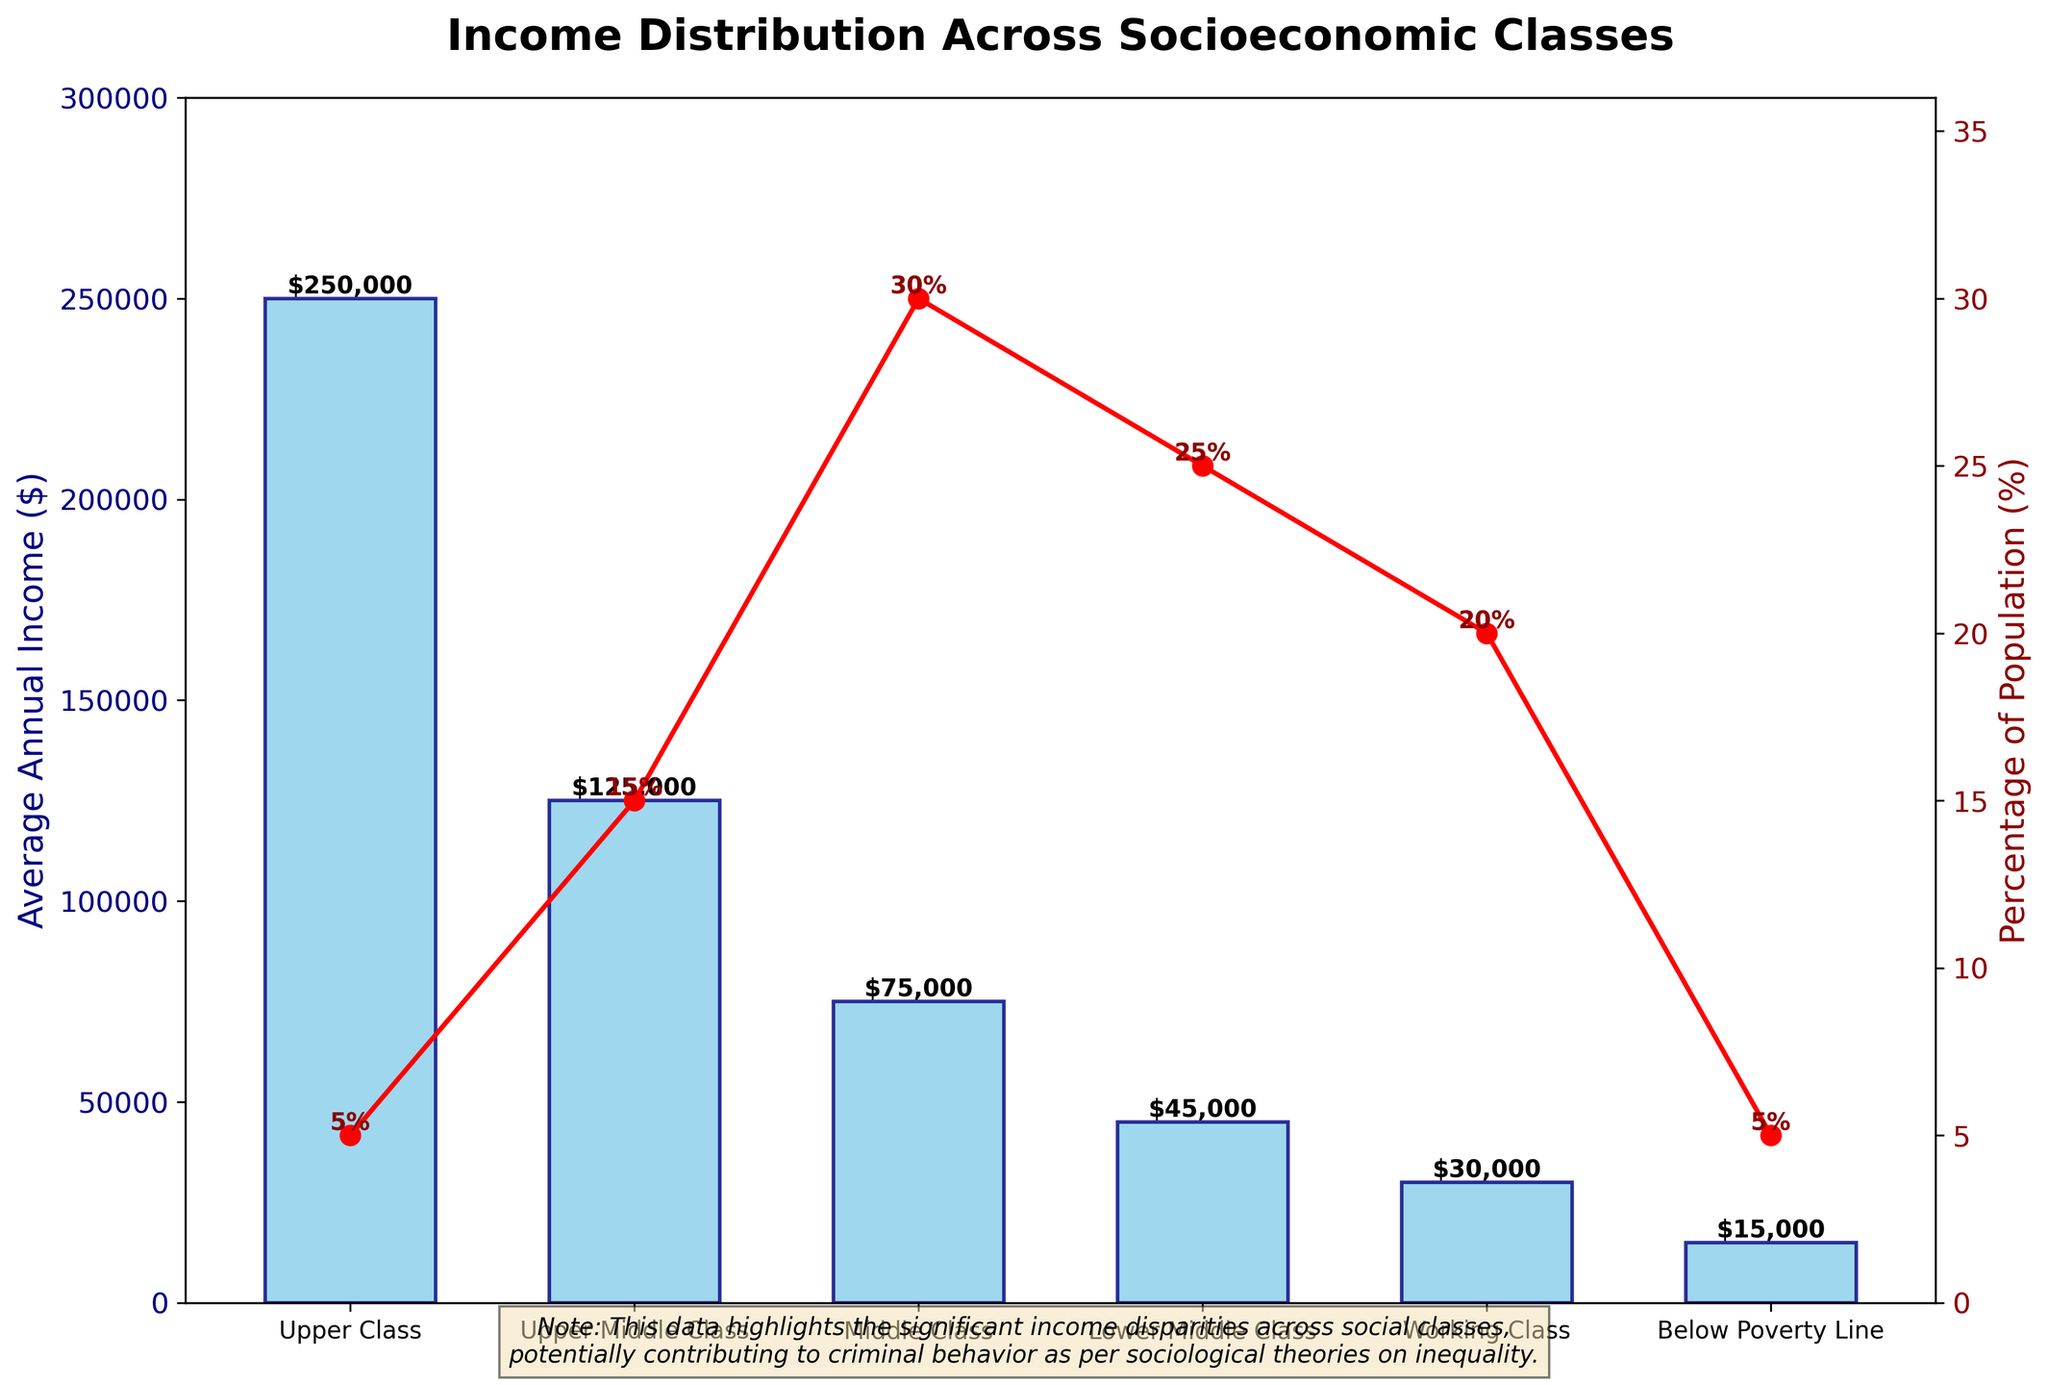What is the average annual income of the Upper Middle Class compared to the Middle Class? The figure shows the average annual income for both the Upper Middle Class and the Middle Class. The Upper Middle Class has an average income of $125,000, while the Middle Class has $75,000. By comparing these values directly, we see that the Upper Middle Class earns more than the Middle Class.
Answer: The Upper Middle Class earns $50,000 more than the Middle Class What percentage of the population falls into the Working Class category? The figure includes a line plot showing the percentage of the population for each socioeconomic class. Observing the point corresponding to the Working Class, we can see that the percentage is marked.
Answer: 20% If we sum the percentages of the Lower Middle Class and the Working Class, what percentage of the population do they collectively represent? The figure indicates that the Lower Middle Class represents 25% of the population, and the Working Class represents 20%. Summing these two percentages provides the collective representation. 25% + 20% = 45%
Answer: 45% Which income class has the highest average annual income, and how does its population percentage compare to the class with the lowest average annual income? The figure shows that the Upper Class has the highest average annual income at $250,000, whereas Below Poverty Line has the lowest at $15,000. To compare their population percentages, we see that the Upper Class represents 5%, and Below Poverty Line also represents 5%.
Answer: Both classes represent 5% of the population Which income class has an average income of $30000, and where is it in terms of population percentage? The figure clearly shows that the Working Class has an average annual income of $30,000. Following the line plot for this income class, we observe the population percentage.
Answer: 20% How does the average annual income of the Upper Class compare to the combined average incomes of the Middle Class and Lower Middle Class? The Upper Class has an average annual income of $250,000. The combined average income of the Middle Class ($75,000) and Lower Middle Class ($45,000) is $120,000. Comparing these two values, the Upper Class has a significantly higher income.
Answer: $130,000 more What is the combined percentage of the two lowest income classes? The figure provides the percentage of the population for each class. The Below Poverty Line class represents 5%, and the Working Class represents 20%. Adding these values together gives the combined percentage. 5% + 20% = 25%
Answer: 25% What visual attributes differentiate the income data and population percentage in the figure? The income data is represented by blue bars, while the percentage of the population is shown by a red line plot with markers. Different Y-axes are used for clarity: one for income (left) and one for percentage (right).
Answer: Blue bars and red line plot Which class has the smallest population percentage, and what is the average annual income for this class? Observing the line plot, we see that both the Upper Class and Below Poverty Line classes have the smallest population percentages at 5%. The average annual income for these classes is shown by the bar heights.
Answer: $250,000 for Upper Class and $15,000 for Below Poverty Line How much more is the average annual income of the Upper Middle Class compared to the Lower Middle Class? To find the difference, we take the Upper Middle Class income ($125,000) and subtract the Lower Middle Class income ($45,000). $125,000 - $45,000 = $80,000
Answer: $80,000 